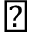Convert formula to latex. <formula><loc_0><loc_0><loc_500><loc_500>\blacktriangle</formula> 